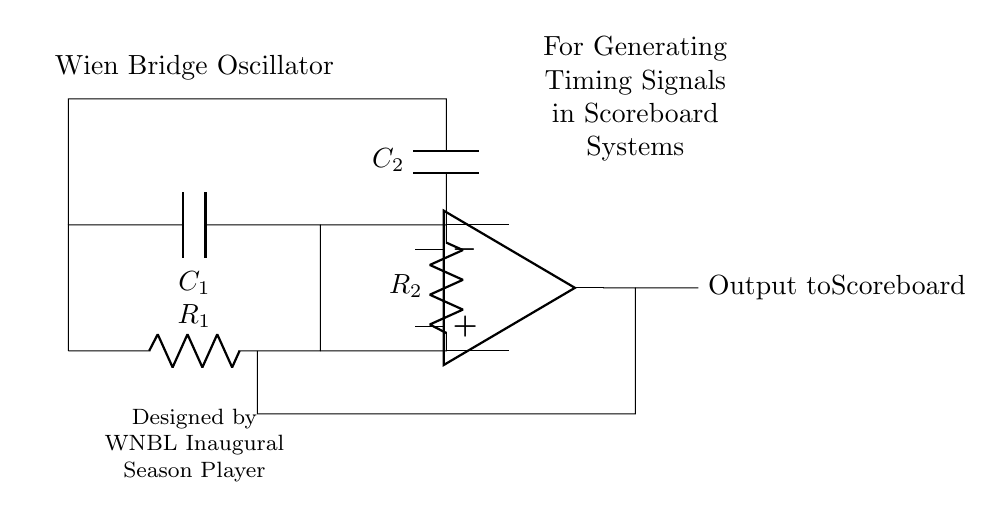What type of oscillator is this circuit? The circuit is a Wien Bridge Oscillator, identified by its specific configuration of resistors and capacitors which is characteristic of this oscillator type.
Answer: Wien Bridge Oscillator Which components are used in this circuit? The circuit includes two resistors (R1 and R2) and two capacitors (C1 and C2), as visually represented in the diagram by their respective symbols.
Answer: Resistors and Capacitors What is the primary output of this circuit? The primary output of this circuit is the signal sent to the scoreboard, labeled as "Output to Scoreboard," which indicates its function in generating timing signals.
Answer: Output to Scoreboard How many resistors are present in the circuit? The diagram clearly shows two resistors, labeled R1 and R2, making it straightforward to count the total number of resistors involved in the design.
Answer: Two What is the purpose of the Wien Bridge Oscillator in scoreboard systems? The purpose of the Wien Bridge Oscillator in this context is to generate timing signals which are essential for the operation of scoreboard systems, as indicated in the labeling on the diagram.
Answer: Timing Signals Why are two capacitors used in the design? Two capacitors are used to create the necessary phase shift in the oscillator circuit, which is vital for the stable oscillation needed to generate timing signals; this is a customary requirement in Wien Bridge Oscillators.
Answer: Stability in Oscillation What does the notation "Designed by WNBL Inaugural Season Player" indicate? This notation acknowledges the origin of the design as being attributed to a player from the inaugural season of the WNBL, suggesting a personal connection or inspiration behind the circuit's creation.
Answer: Acknowledgment of Design Origin 